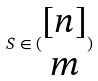Convert formula to latex. <formula><loc_0><loc_0><loc_500><loc_500>S \in ( \begin{matrix} [ n ] \\ m \end{matrix} )</formula> 